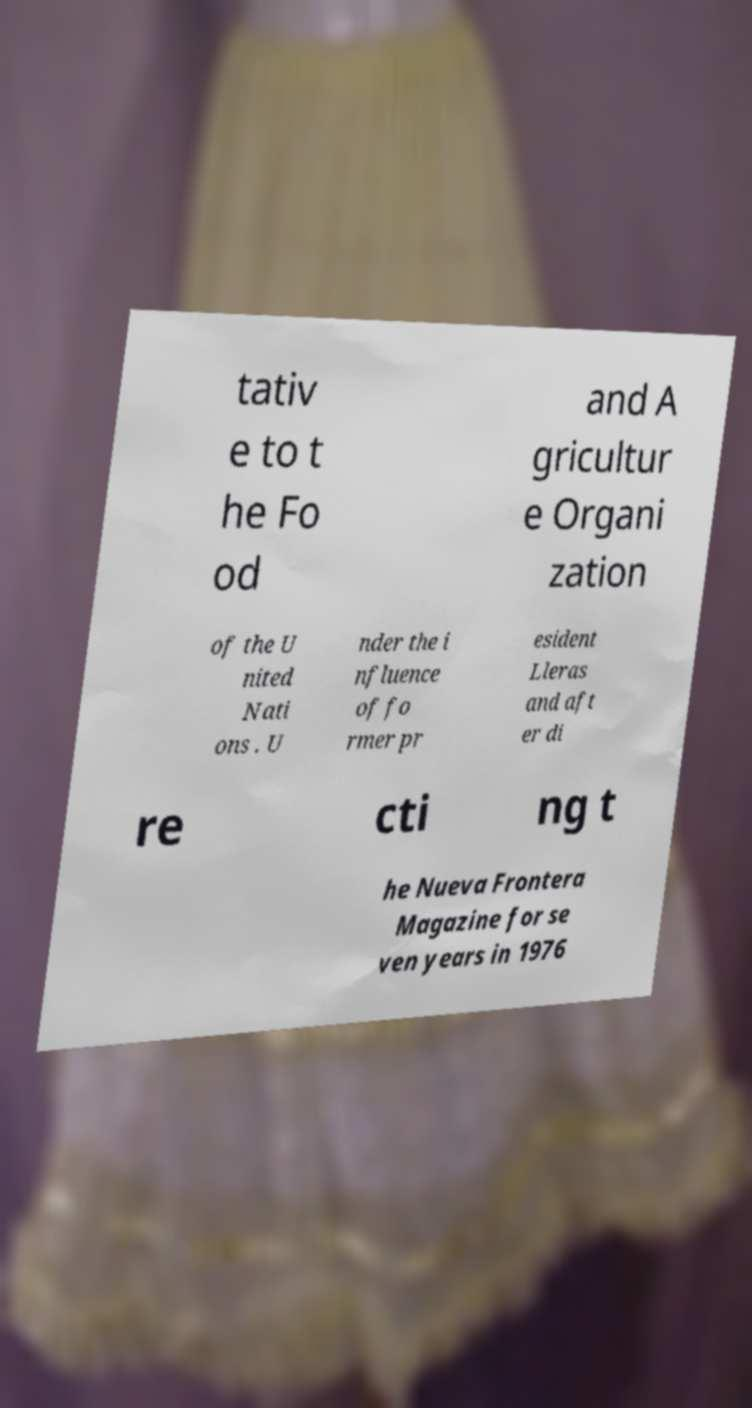Please read and relay the text visible in this image. What does it say? tativ e to t he Fo od and A gricultur e Organi zation of the U nited Nati ons . U nder the i nfluence of fo rmer pr esident Lleras and aft er di re cti ng t he Nueva Frontera Magazine for se ven years in 1976 